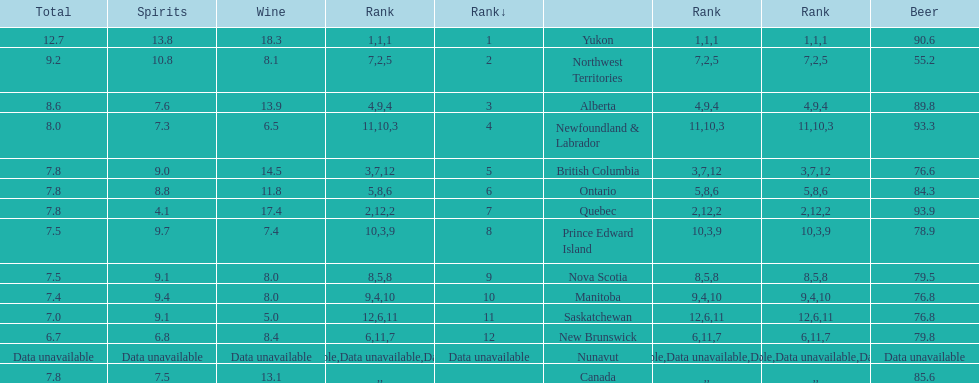Which province is the top consumer of wine? Yukon. 